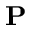Convert formula to latex. <formula><loc_0><loc_0><loc_500><loc_500>{ P }</formula> 